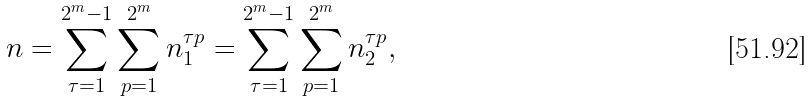<formula> <loc_0><loc_0><loc_500><loc_500>n = \sum _ { \tau = 1 } ^ { 2 ^ { m } - 1 } \sum _ { p = 1 } ^ { 2 ^ { m } } n _ { 1 } ^ { \tau p } = \sum _ { \tau = 1 } ^ { 2 ^ { m } - 1 } \sum _ { p = 1 } ^ { 2 ^ { m } } n _ { 2 } ^ { \tau p } ,</formula> 